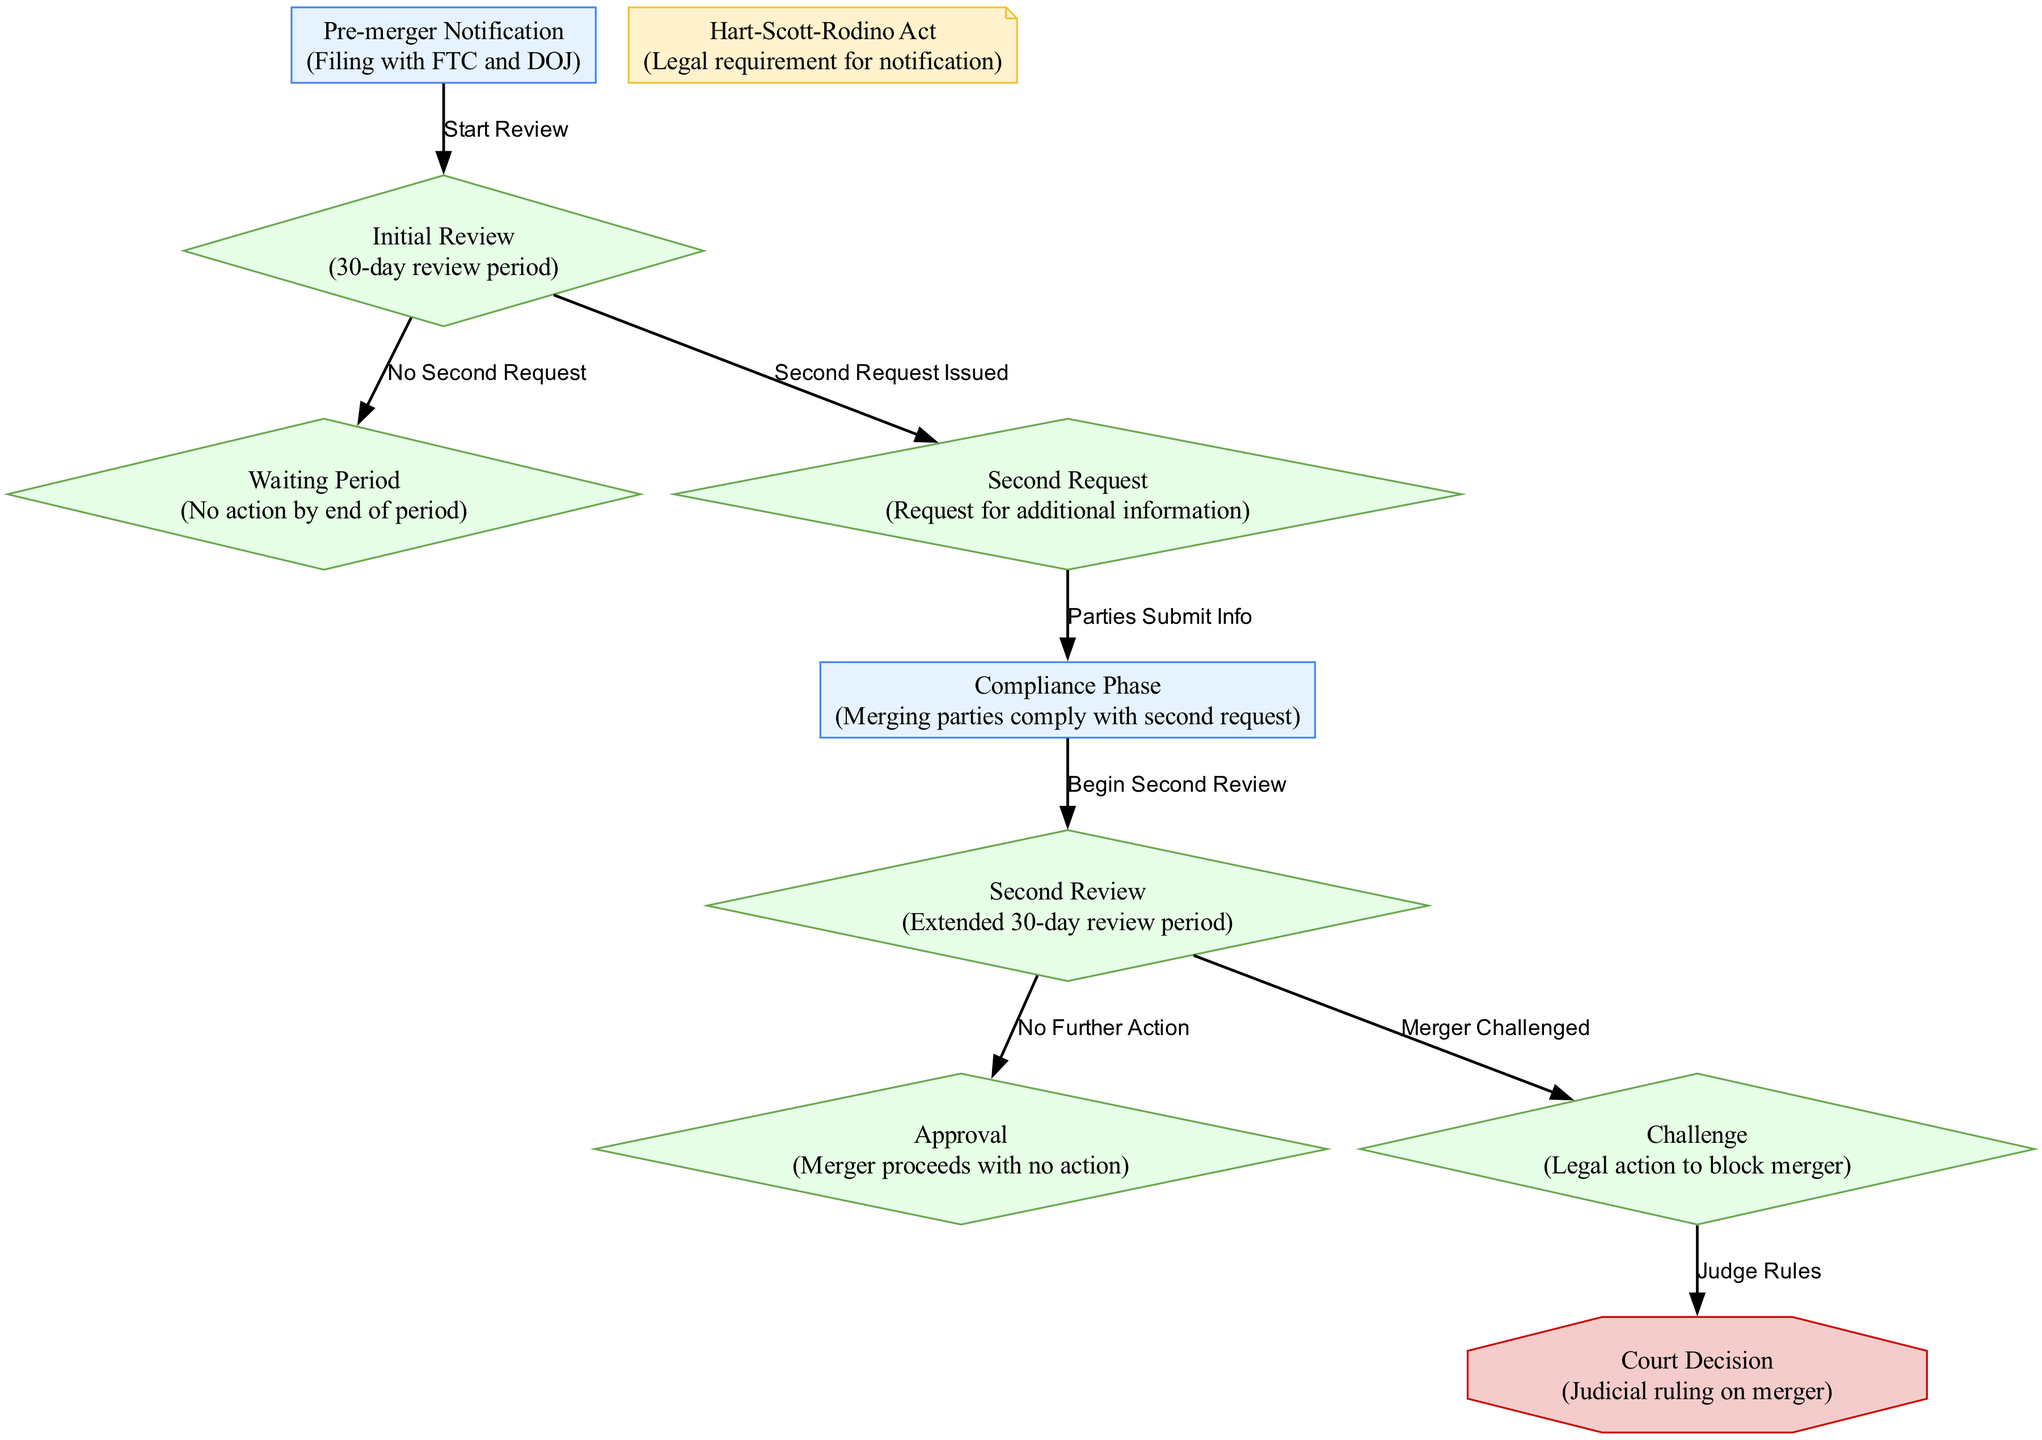What is the first step in the merger review process? The first step is the "Pre-merger Notification," which involves filing with the FTC and DOJ.
Answer: Pre-merger Notification How long is the initial review period? The initial review period lasts for 30 days according to the "Initial Review" step in the diagram.
Answer: 30 days What happens if the "Initial Review" results in no second request? If no second request is issued, the process moves to the "Waiting Period," indicating no action taken.
Answer: Waiting Period What occurs after the "Second Request"? After the "Second Request," the next phase is the "Compliance Phase," where merging parties must submit additional information.
Answer: Compliance Phase What are the possible outcomes after the "Second Review"? The possible outcomes are "Approval" if there's no further action or "Challenge" if the merger is contested.
Answer: Approval or Challenge How many major nodes are there in the diagram? By counting all the unique processes and outcomes displayed, there are ten major nodes in total.
Answer: 10 What triggers the "Second Review"? The "Second Review" is triggered after the "Compliance Phase" when the FTC or DOJ assesses the information provided in response to the second request.
Answer: Compliance Phase In which phase do judicial rulings occur? Judicial rulings occur in the "Court Decision" phase, which follows a legal challenge to the merger.
Answer: Court Decision What legal requirement must be fulfilled before the merger review begins? The requirement is specified by the "Hart-Scott-Rodino Act," which mandates notification to the FTC and DOJ.
Answer: Hart-Scott-Rodino Act 